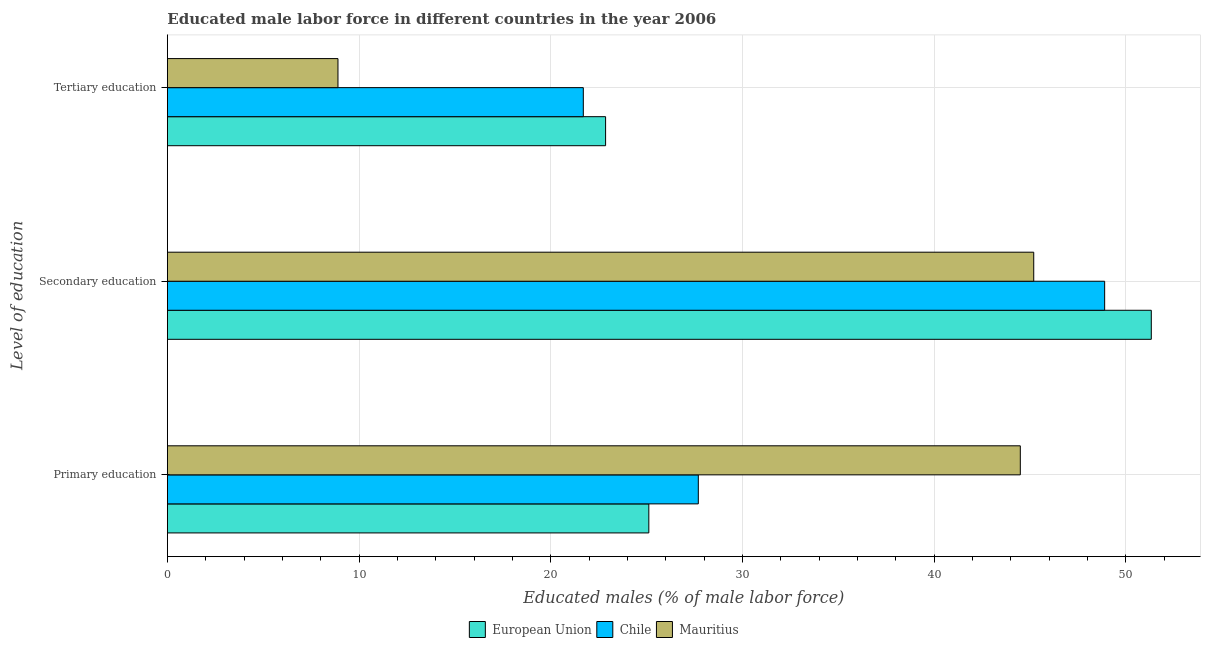How many groups of bars are there?
Provide a short and direct response. 3. What is the label of the 1st group of bars from the top?
Make the answer very short. Tertiary education. What is the percentage of male labor force who received tertiary education in European Union?
Provide a succinct answer. 22.86. Across all countries, what is the maximum percentage of male labor force who received tertiary education?
Your response must be concise. 22.86. Across all countries, what is the minimum percentage of male labor force who received tertiary education?
Give a very brief answer. 8.9. In which country was the percentage of male labor force who received secondary education minimum?
Keep it short and to the point. Mauritius. What is the total percentage of male labor force who received secondary education in the graph?
Ensure brevity in your answer.  145.43. What is the difference between the percentage of male labor force who received tertiary education in European Union and that in Chile?
Keep it short and to the point. 1.16. What is the difference between the percentage of male labor force who received secondary education in European Union and the percentage of male labor force who received tertiary education in Chile?
Make the answer very short. 29.63. What is the average percentage of male labor force who received tertiary education per country?
Provide a short and direct response. 17.82. What is the difference between the percentage of male labor force who received secondary education and percentage of male labor force who received tertiary education in European Union?
Ensure brevity in your answer.  28.47. In how many countries, is the percentage of male labor force who received tertiary education greater than 14 %?
Your response must be concise. 2. What is the ratio of the percentage of male labor force who received secondary education in European Union to that in Chile?
Offer a terse response. 1.05. Is the percentage of male labor force who received tertiary education in Mauritius less than that in European Union?
Provide a short and direct response. Yes. What is the difference between the highest and the second highest percentage of male labor force who received secondary education?
Provide a short and direct response. 2.43. What is the difference between the highest and the lowest percentage of male labor force who received tertiary education?
Keep it short and to the point. 13.96. Is the sum of the percentage of male labor force who received secondary education in Chile and Mauritius greater than the maximum percentage of male labor force who received primary education across all countries?
Your answer should be very brief. Yes. What does the 3rd bar from the top in Primary education represents?
Your answer should be very brief. European Union. What does the 3rd bar from the bottom in Secondary education represents?
Give a very brief answer. Mauritius. Are all the bars in the graph horizontal?
Your answer should be very brief. Yes. Where does the legend appear in the graph?
Your answer should be very brief. Bottom center. What is the title of the graph?
Make the answer very short. Educated male labor force in different countries in the year 2006. Does "Ukraine" appear as one of the legend labels in the graph?
Your response must be concise. No. What is the label or title of the X-axis?
Give a very brief answer. Educated males (% of male labor force). What is the label or title of the Y-axis?
Make the answer very short. Level of education. What is the Educated males (% of male labor force) of European Union in Primary education?
Keep it short and to the point. 25.12. What is the Educated males (% of male labor force) of Chile in Primary education?
Provide a succinct answer. 27.7. What is the Educated males (% of male labor force) in Mauritius in Primary education?
Give a very brief answer. 44.5. What is the Educated males (% of male labor force) in European Union in Secondary education?
Your answer should be compact. 51.33. What is the Educated males (% of male labor force) of Chile in Secondary education?
Give a very brief answer. 48.9. What is the Educated males (% of male labor force) of Mauritius in Secondary education?
Ensure brevity in your answer.  45.2. What is the Educated males (% of male labor force) of European Union in Tertiary education?
Offer a very short reply. 22.86. What is the Educated males (% of male labor force) in Chile in Tertiary education?
Offer a very short reply. 21.7. What is the Educated males (% of male labor force) in Mauritius in Tertiary education?
Offer a terse response. 8.9. Across all Level of education, what is the maximum Educated males (% of male labor force) of European Union?
Ensure brevity in your answer.  51.33. Across all Level of education, what is the maximum Educated males (% of male labor force) in Chile?
Provide a short and direct response. 48.9. Across all Level of education, what is the maximum Educated males (% of male labor force) of Mauritius?
Your response must be concise. 45.2. Across all Level of education, what is the minimum Educated males (% of male labor force) in European Union?
Offer a very short reply. 22.86. Across all Level of education, what is the minimum Educated males (% of male labor force) in Chile?
Provide a short and direct response. 21.7. Across all Level of education, what is the minimum Educated males (% of male labor force) of Mauritius?
Provide a short and direct response. 8.9. What is the total Educated males (% of male labor force) of European Union in the graph?
Your answer should be very brief. 99.32. What is the total Educated males (% of male labor force) of Chile in the graph?
Offer a very short reply. 98.3. What is the total Educated males (% of male labor force) in Mauritius in the graph?
Your answer should be very brief. 98.6. What is the difference between the Educated males (% of male labor force) of European Union in Primary education and that in Secondary education?
Offer a terse response. -26.22. What is the difference between the Educated males (% of male labor force) of Chile in Primary education and that in Secondary education?
Your response must be concise. -21.2. What is the difference between the Educated males (% of male labor force) of Mauritius in Primary education and that in Secondary education?
Provide a short and direct response. -0.7. What is the difference between the Educated males (% of male labor force) in European Union in Primary education and that in Tertiary education?
Offer a terse response. 2.26. What is the difference between the Educated males (% of male labor force) in Mauritius in Primary education and that in Tertiary education?
Your answer should be compact. 35.6. What is the difference between the Educated males (% of male labor force) in European Union in Secondary education and that in Tertiary education?
Your answer should be very brief. 28.47. What is the difference between the Educated males (% of male labor force) in Chile in Secondary education and that in Tertiary education?
Keep it short and to the point. 27.2. What is the difference between the Educated males (% of male labor force) of Mauritius in Secondary education and that in Tertiary education?
Make the answer very short. 36.3. What is the difference between the Educated males (% of male labor force) in European Union in Primary education and the Educated males (% of male labor force) in Chile in Secondary education?
Your response must be concise. -23.78. What is the difference between the Educated males (% of male labor force) of European Union in Primary education and the Educated males (% of male labor force) of Mauritius in Secondary education?
Your answer should be very brief. -20.08. What is the difference between the Educated males (% of male labor force) of Chile in Primary education and the Educated males (% of male labor force) of Mauritius in Secondary education?
Your answer should be very brief. -17.5. What is the difference between the Educated males (% of male labor force) in European Union in Primary education and the Educated males (% of male labor force) in Chile in Tertiary education?
Offer a very short reply. 3.42. What is the difference between the Educated males (% of male labor force) of European Union in Primary education and the Educated males (% of male labor force) of Mauritius in Tertiary education?
Give a very brief answer. 16.22. What is the difference between the Educated males (% of male labor force) in Chile in Primary education and the Educated males (% of male labor force) in Mauritius in Tertiary education?
Offer a very short reply. 18.8. What is the difference between the Educated males (% of male labor force) in European Union in Secondary education and the Educated males (% of male labor force) in Chile in Tertiary education?
Offer a very short reply. 29.63. What is the difference between the Educated males (% of male labor force) in European Union in Secondary education and the Educated males (% of male labor force) in Mauritius in Tertiary education?
Your response must be concise. 42.43. What is the difference between the Educated males (% of male labor force) of Chile in Secondary education and the Educated males (% of male labor force) of Mauritius in Tertiary education?
Give a very brief answer. 40. What is the average Educated males (% of male labor force) of European Union per Level of education?
Make the answer very short. 33.11. What is the average Educated males (% of male labor force) of Chile per Level of education?
Provide a short and direct response. 32.77. What is the average Educated males (% of male labor force) in Mauritius per Level of education?
Provide a short and direct response. 32.87. What is the difference between the Educated males (% of male labor force) in European Union and Educated males (% of male labor force) in Chile in Primary education?
Give a very brief answer. -2.58. What is the difference between the Educated males (% of male labor force) of European Union and Educated males (% of male labor force) of Mauritius in Primary education?
Ensure brevity in your answer.  -19.38. What is the difference between the Educated males (% of male labor force) in Chile and Educated males (% of male labor force) in Mauritius in Primary education?
Your answer should be very brief. -16.8. What is the difference between the Educated males (% of male labor force) of European Union and Educated males (% of male labor force) of Chile in Secondary education?
Offer a very short reply. 2.43. What is the difference between the Educated males (% of male labor force) of European Union and Educated males (% of male labor force) of Mauritius in Secondary education?
Your response must be concise. 6.13. What is the difference between the Educated males (% of male labor force) in European Union and Educated males (% of male labor force) in Chile in Tertiary education?
Give a very brief answer. 1.16. What is the difference between the Educated males (% of male labor force) in European Union and Educated males (% of male labor force) in Mauritius in Tertiary education?
Offer a terse response. 13.96. What is the ratio of the Educated males (% of male labor force) of European Union in Primary education to that in Secondary education?
Keep it short and to the point. 0.49. What is the ratio of the Educated males (% of male labor force) of Chile in Primary education to that in Secondary education?
Offer a terse response. 0.57. What is the ratio of the Educated males (% of male labor force) of Mauritius in Primary education to that in Secondary education?
Offer a terse response. 0.98. What is the ratio of the Educated males (% of male labor force) in European Union in Primary education to that in Tertiary education?
Your response must be concise. 1.1. What is the ratio of the Educated males (% of male labor force) of Chile in Primary education to that in Tertiary education?
Offer a very short reply. 1.28. What is the ratio of the Educated males (% of male labor force) of European Union in Secondary education to that in Tertiary education?
Make the answer very short. 2.25. What is the ratio of the Educated males (% of male labor force) of Chile in Secondary education to that in Tertiary education?
Provide a short and direct response. 2.25. What is the ratio of the Educated males (% of male labor force) of Mauritius in Secondary education to that in Tertiary education?
Your response must be concise. 5.08. What is the difference between the highest and the second highest Educated males (% of male labor force) in European Union?
Ensure brevity in your answer.  26.22. What is the difference between the highest and the second highest Educated males (% of male labor force) in Chile?
Your response must be concise. 21.2. What is the difference between the highest and the lowest Educated males (% of male labor force) of European Union?
Your answer should be compact. 28.47. What is the difference between the highest and the lowest Educated males (% of male labor force) of Chile?
Make the answer very short. 27.2. What is the difference between the highest and the lowest Educated males (% of male labor force) of Mauritius?
Make the answer very short. 36.3. 